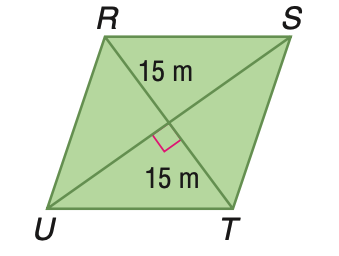Question: Rhombus R S T U has an area of 675 square meters. Find S U.
Choices:
A. 22.5
B. 25.98
C. 30
D. 45
Answer with the letter. Answer: D 